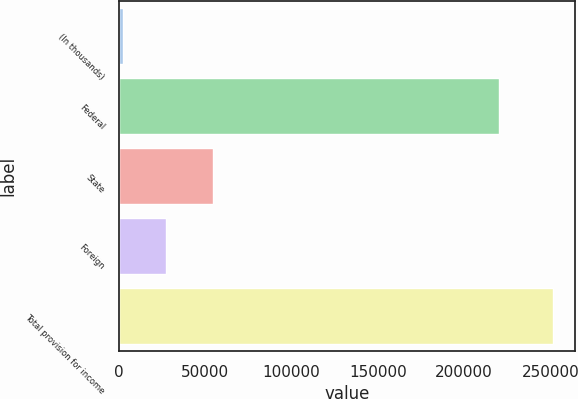Convert chart to OTSL. <chart><loc_0><loc_0><loc_500><loc_500><bar_chart><fcel>(In thousands)<fcel>Federal<fcel>State<fcel>Foreign<fcel>Total provision for income<nl><fcel>2007<fcel>220064<fcel>54372<fcel>26967<fcel>251607<nl></chart> 